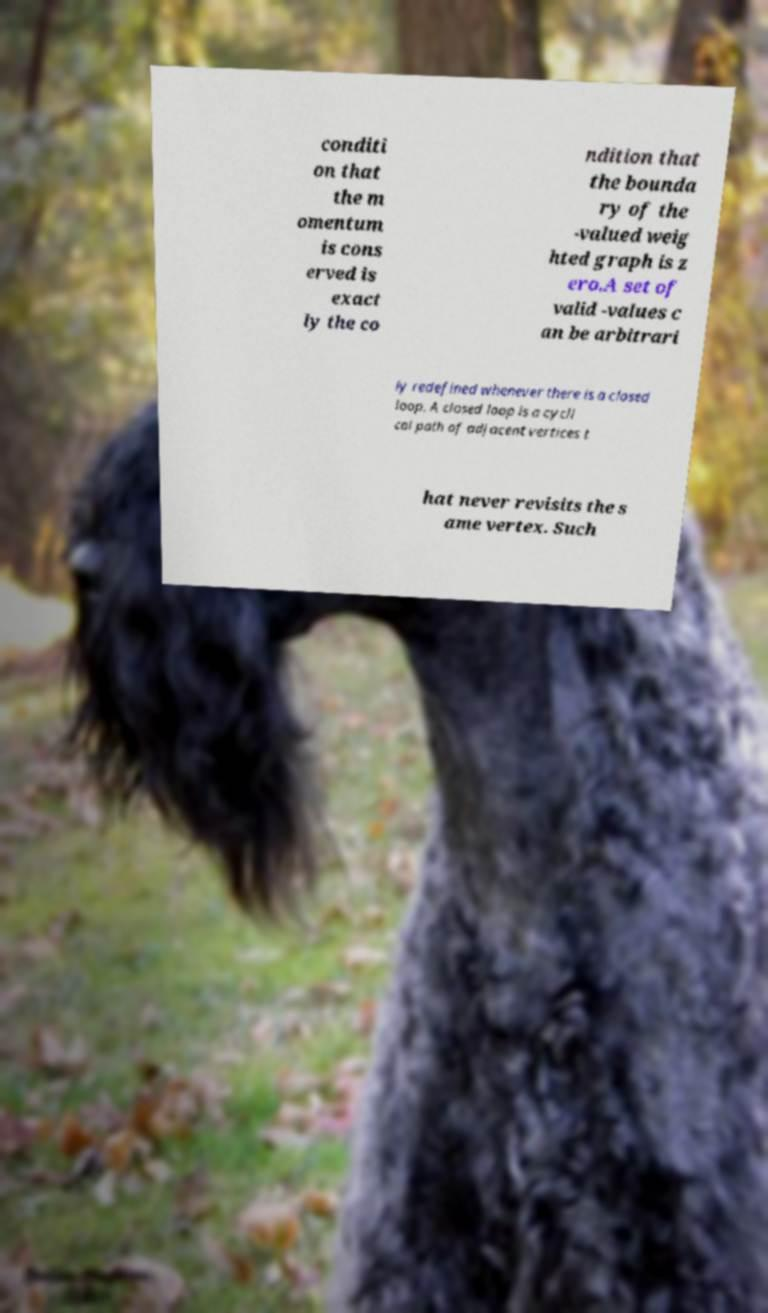Can you accurately transcribe the text from the provided image for me? conditi on that the m omentum is cons erved is exact ly the co ndition that the bounda ry of the -valued weig hted graph is z ero.A set of valid -values c an be arbitrari ly redefined whenever there is a closed loop. A closed loop is a cycli cal path of adjacent vertices t hat never revisits the s ame vertex. Such 